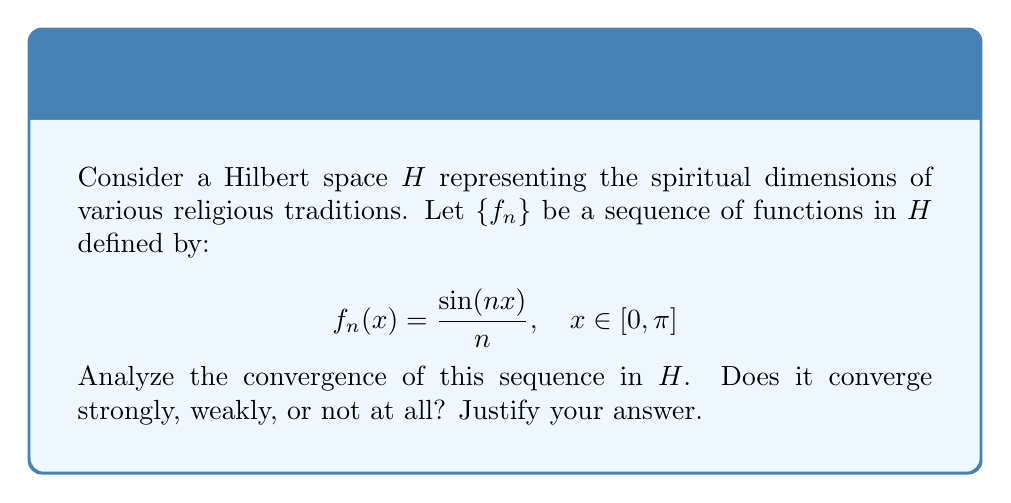Could you help me with this problem? Let's approach this step-by-step:

1) First, recall that in a Hilbert space, we have three types of convergence: norm (strong) convergence, weak convergence, and pointwise convergence.

2) For strong convergence, we need to show that $\|f_n - f\| \to 0$ as $n \to \infty$ for some $f \in H$.

3) Let's calculate the norm of $f_n$:

   $$\|f_n\|^2 = \int_0^\pi |\frac{\sin(nx)}{n}|^2 dx = \frac{1}{n^2} \int_0^\pi \sin^2(nx) dx = \frac{\pi}{2n^2}$$

4) As $n \to \infty$, $\|f_n\| \to 0$. This suggests that if $f_n$ converges strongly, it must converge to the zero function.

5) Indeed, for any $x \in [0, \pi]$, $|f_n(x)| \leq \frac{1}{n} \to 0$ as $n \to \infty$. So $f_n$ converges pointwise to the zero function.

6) However, pointwise convergence doesn't imply strong convergence in general. We need to show uniform convergence.

7) The sequence $\{\frac{\sin(nx)}{n}\}$ is uniformly bounded by $\frac{1}{n}$, which tends to 0 as $n \to \infty$. This implies uniform convergence to the zero function.

8) In a Hilbert space, uniform convergence implies strong convergence. Therefore, $f_n$ converges strongly to the zero function.

9) Since strong convergence implies weak convergence, $f_n$ also converges weakly to the zero function.

In the context of comparative theology, this convergence could be interpreted as different religious traditions (represented by the functions $f_n$) ultimately converging to a common spiritual truth (the zero function) when viewed from a sufficiently broad perspective (as $n \to \infty$).
Answer: The sequence $\{f_n\}$ converges strongly (and thus weakly) to the zero function in $H$. 